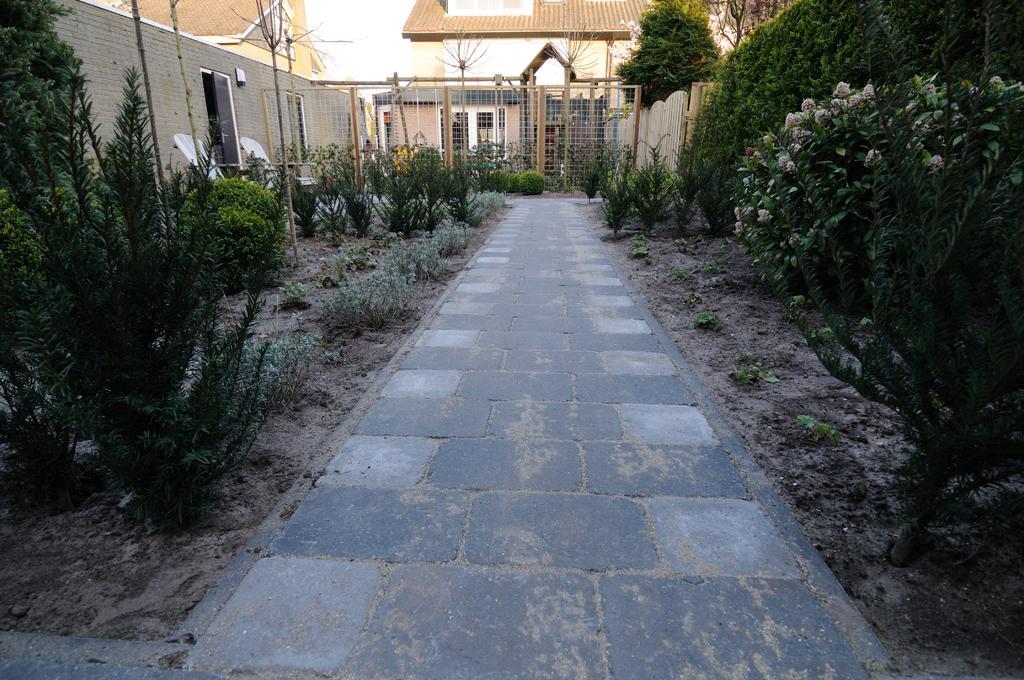Could you give a brief overview of what you see in this image? In this image in the middle there is a path. In either sides there are plants trees. In the background there are buildings. Here there is a net boundary. 